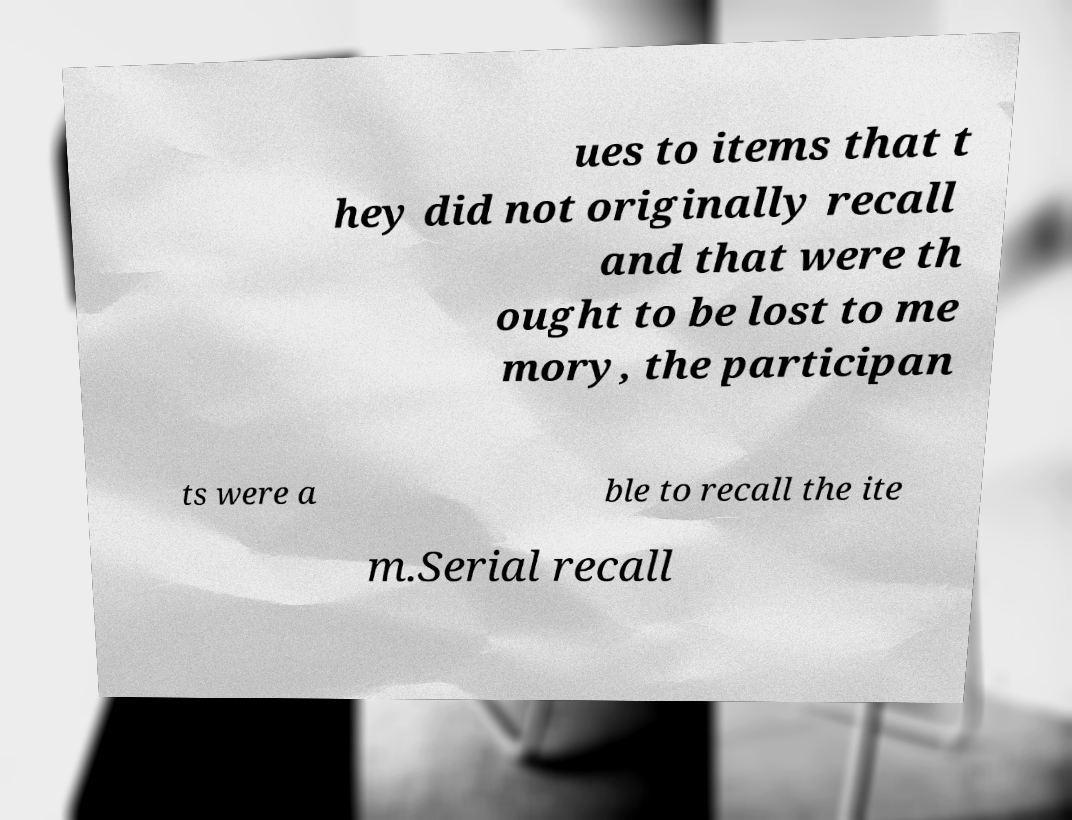What messages or text are displayed in this image? I need them in a readable, typed format. ues to items that t hey did not originally recall and that were th ought to be lost to me mory, the participan ts were a ble to recall the ite m.Serial recall 